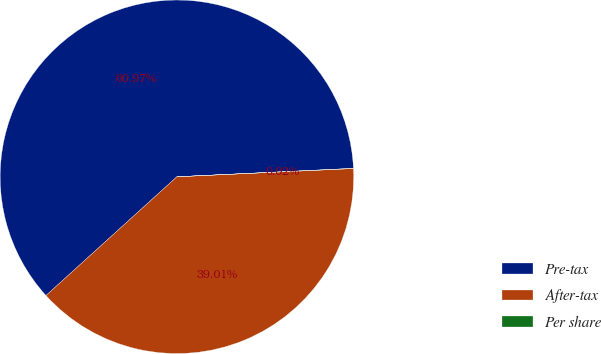<chart> <loc_0><loc_0><loc_500><loc_500><pie_chart><fcel>Pre-tax<fcel>After-tax<fcel>Per share<nl><fcel>60.96%<fcel>39.01%<fcel>0.02%<nl></chart> 